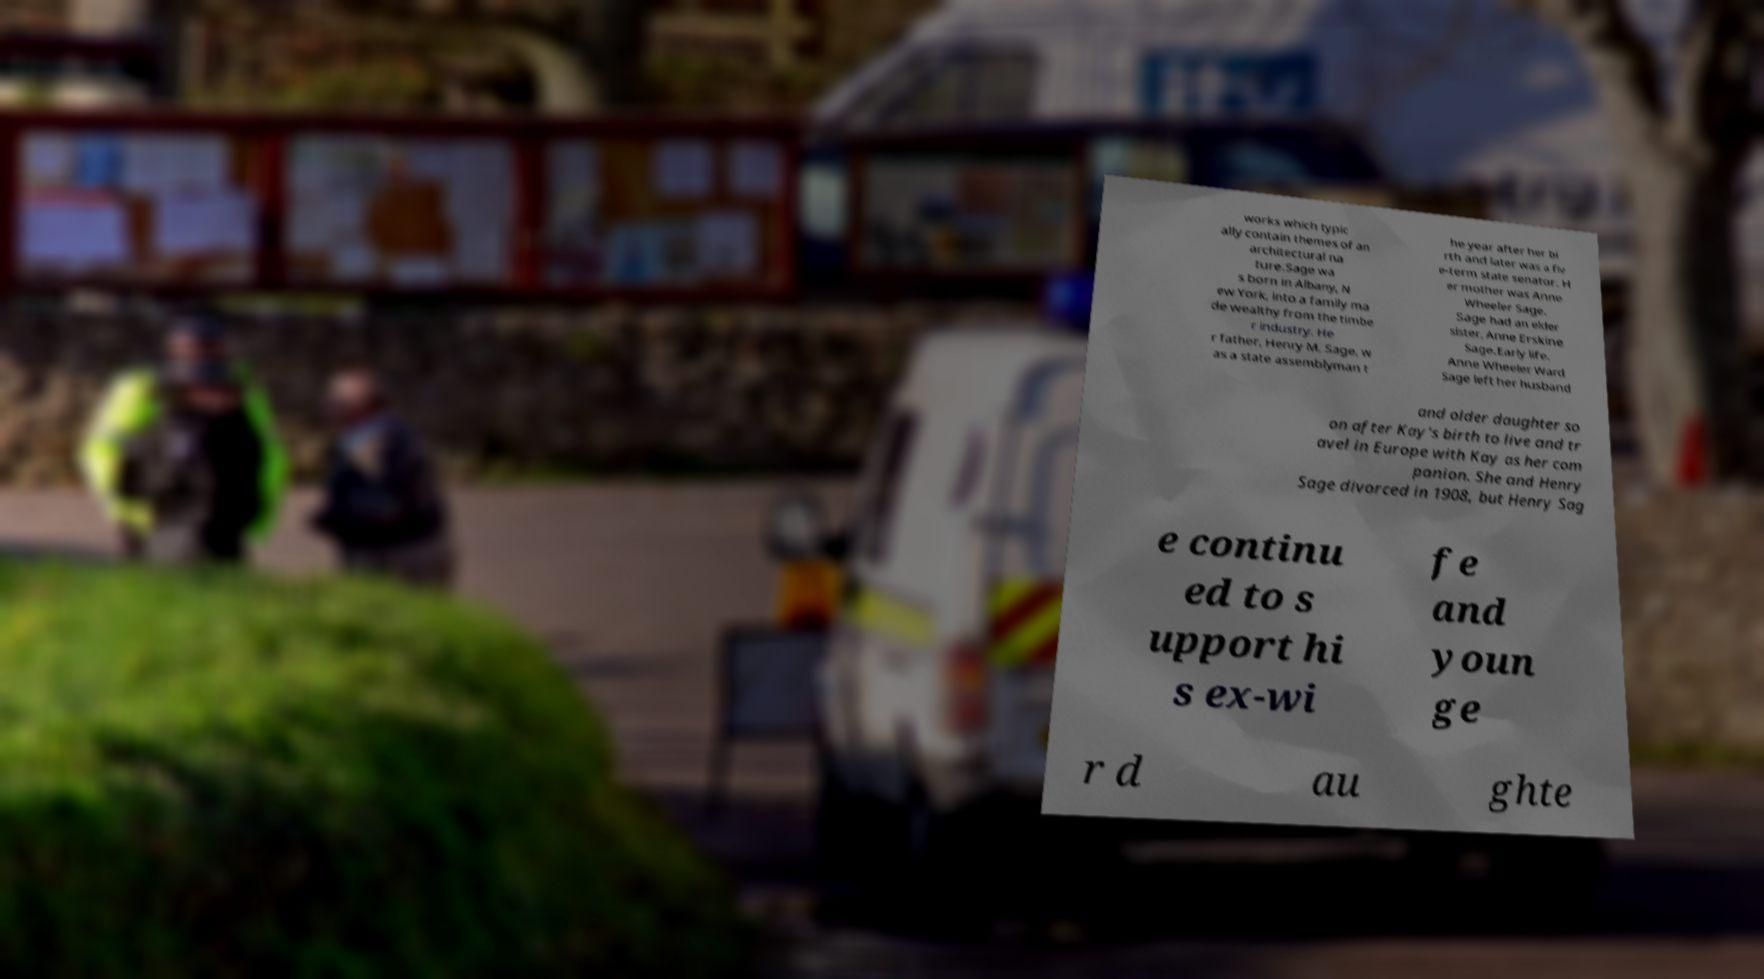What messages or text are displayed in this image? I need them in a readable, typed format. works which typic ally contain themes of an architectural na ture.Sage wa s born in Albany, N ew York, into a family ma de wealthy from the timbe r industry. He r father, Henry M. Sage, w as a state assemblyman t he year after her bi rth and later was a fiv e-term state senator. H er mother was Anne Wheeler Sage. Sage had an elder sister, Anne Erskine Sage.Early life. Anne Wheeler Ward Sage left her husband and older daughter so on after Kay's birth to live and tr avel in Europe with Kay as her com panion. She and Henry Sage divorced in 1908, but Henry Sag e continu ed to s upport hi s ex-wi fe and youn ge r d au ghte 